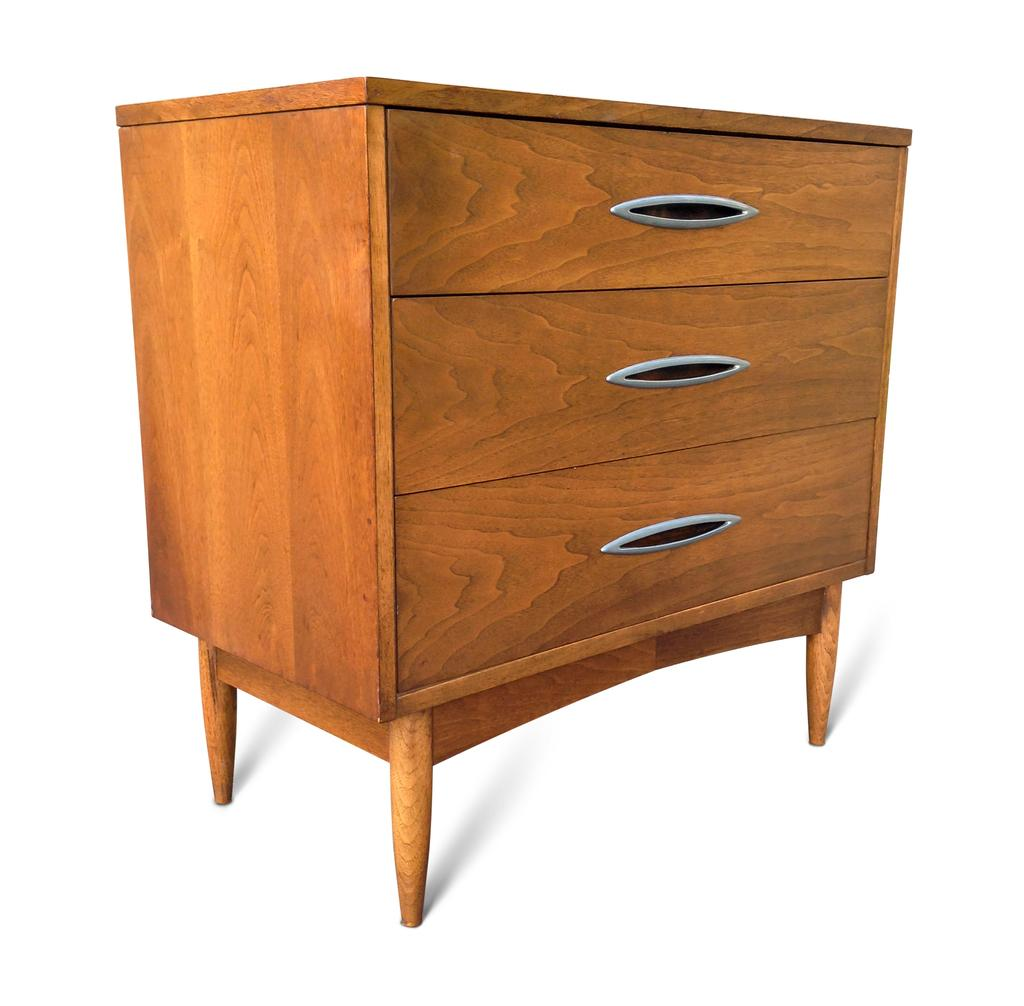What type of material is the cupboard made of in the image? The cupboard is made of wood in the image. How many drawers are present on the cupboard? The cupboard has three drawers in the image. What type of curtain is hanging in front of the cupboard in the image? There is no curtain present in front of the cupboard in the image. What type of order is being followed in the arrangement of the drawers on the cupboard? The image does not provide information about any specific order being followed in the arrangement of the drawers on the cupboard. 